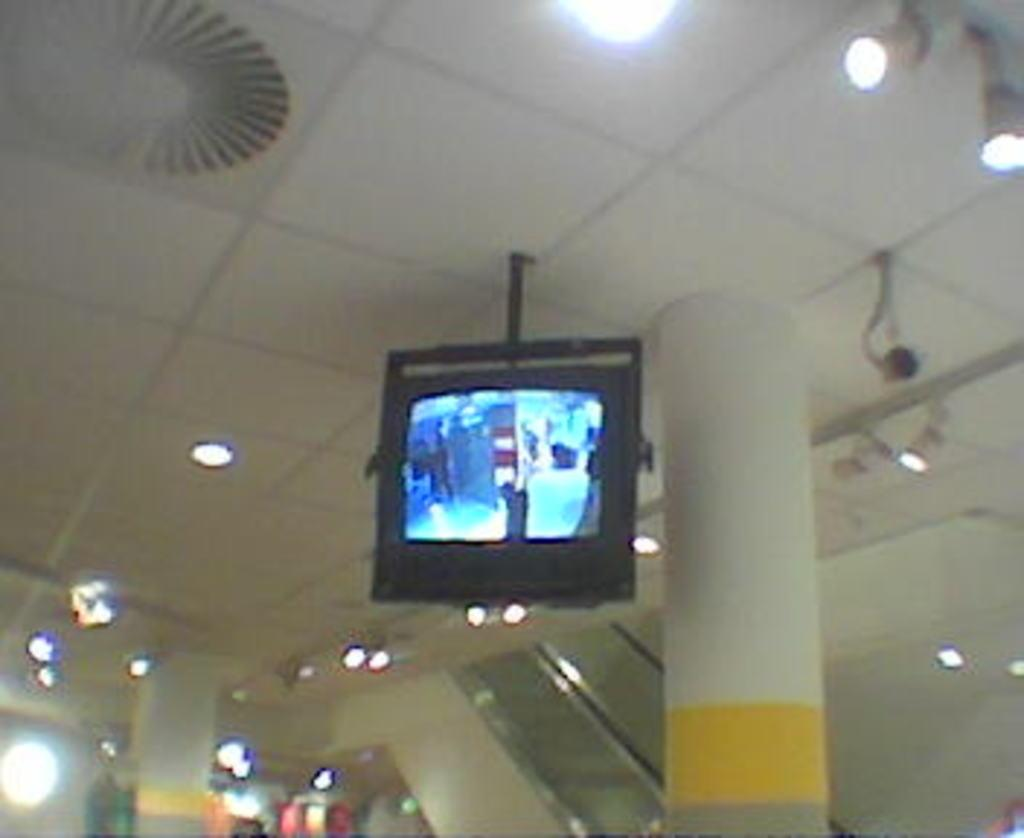What type of television is in the image? There is a black color television in the image. Where is the television located? The television is hanging on the roof. What color is the pillar in the image? The pillar is white in color. What color is the roof in the image? The roof is white in color. Can you describe the lighting in the image? There are some lights visible in the image. How many houses are visible in the image? There is no mention of houses in the image; it only features a television hanging on a white roof with a white pillar and some lights. Can you tell me the color of the toad in the image? There is no toad present in the image. 